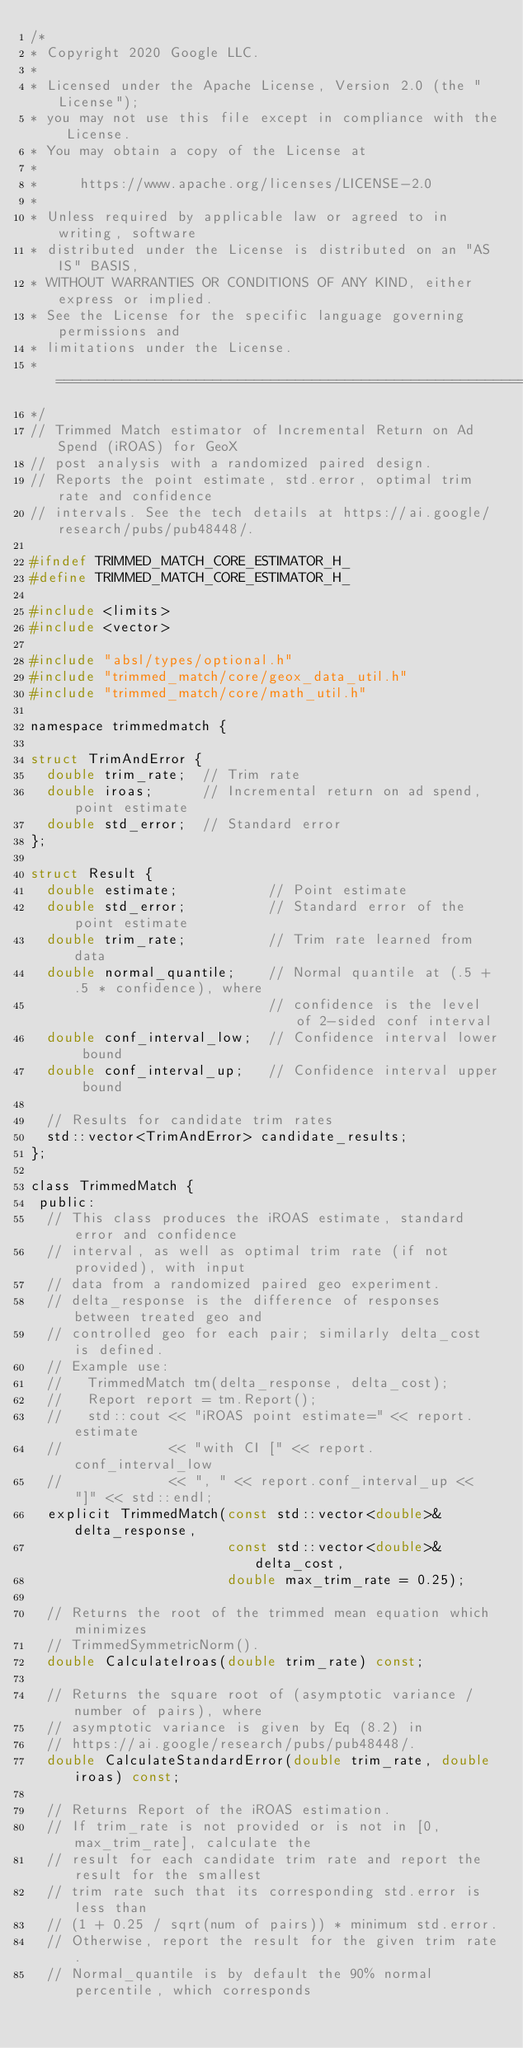Convert code to text. <code><loc_0><loc_0><loc_500><loc_500><_C_>/*
* Copyright 2020 Google LLC.
*
* Licensed under the Apache License, Version 2.0 (the "License");
* you may not use this file except in compliance with the License.
* You may obtain a copy of the License at
*
*     https://www.apache.org/licenses/LICENSE-2.0
*
* Unless required by applicable law or agreed to in writing, software
* distributed under the License is distributed on an "AS IS" BASIS,
* WITHOUT WARRANTIES OR CONDITIONS OF ANY KIND, either express or implied.
* See the License for the specific language governing permissions and
* limitations under the License.
* ============================================================================
*/
// Trimmed Match estimator of Incremental Return on Ad Spend (iROAS) for GeoX
// post analysis with a randomized paired design.
// Reports the point estimate, std.error, optimal trim rate and confidence
// intervals. See the tech details at https://ai.google/research/pubs/pub48448/.

#ifndef TRIMMED_MATCH_CORE_ESTIMATOR_H_
#define TRIMMED_MATCH_CORE_ESTIMATOR_H_

#include <limits>
#include <vector>

#include "absl/types/optional.h"
#include "trimmed_match/core/geox_data_util.h"
#include "trimmed_match/core/math_util.h"

namespace trimmedmatch {

struct TrimAndError {
  double trim_rate;  // Trim rate
  double iroas;      // Incremental return on ad spend, point estimate
  double std_error;  // Standard error
};

struct Result {
  double estimate;           // Point estimate
  double std_error;          // Standard error of the point estimate
  double trim_rate;          // Trim rate learned from data
  double normal_quantile;    // Normal quantile at (.5 + .5 * confidence), where
                             // confidence is the level of 2-sided conf interval
  double conf_interval_low;  // Confidence interval lower bound
  double conf_interval_up;   // Confidence interval upper bound

  // Results for candidate trim rates
  std::vector<TrimAndError> candidate_results;
};

class TrimmedMatch {
 public:
  // This class produces the iROAS estimate, standard error and confidence
  // interval, as well as optimal trim rate (if not provided), with input
  // data from a randomized paired geo experiment.
  // delta_response is the difference of responses between treated geo and
  // controlled geo for each pair; similarly delta_cost is defined.
  // Example use:
  //   TrimmedMatch tm(delta_response, delta_cost);
  //   Report report = tm.Report();
  //   std::cout << "iROAS point estimate=" << report.estimate
  //             << "with CI [" << report.conf_interval_low
  //             << ", " << report.conf_interval_up << "]" << std::endl;
  explicit TrimmedMatch(const std::vector<double>& delta_response,
                        const std::vector<double>& delta_cost,
                        double max_trim_rate = 0.25);

  // Returns the root of the trimmed mean equation which minimizes
  // TrimmedSymmetricNorm().
  double CalculateIroas(double trim_rate) const;

  // Returns the square root of (asymptotic variance / number of pairs), where
  // asymptotic variance is given by Eq (8.2) in
  // https://ai.google/research/pubs/pub48448/.
  double CalculateStandardError(double trim_rate, double iroas) const;

  // Returns Report of the iROAS estimation.
  // If trim_rate is not provided or is not in [0, max_trim_rate], calculate the
  // result for each candidate trim rate and report the result for the smallest
  // trim rate such that its corresponding std.error is less than
  // (1 + 0.25 / sqrt(num of pairs)) * minimum std.error.
  // Otherwise, report the result for the given trim rate.
  // Normal_quantile is by default the 90% normal percentile, which corresponds</code> 